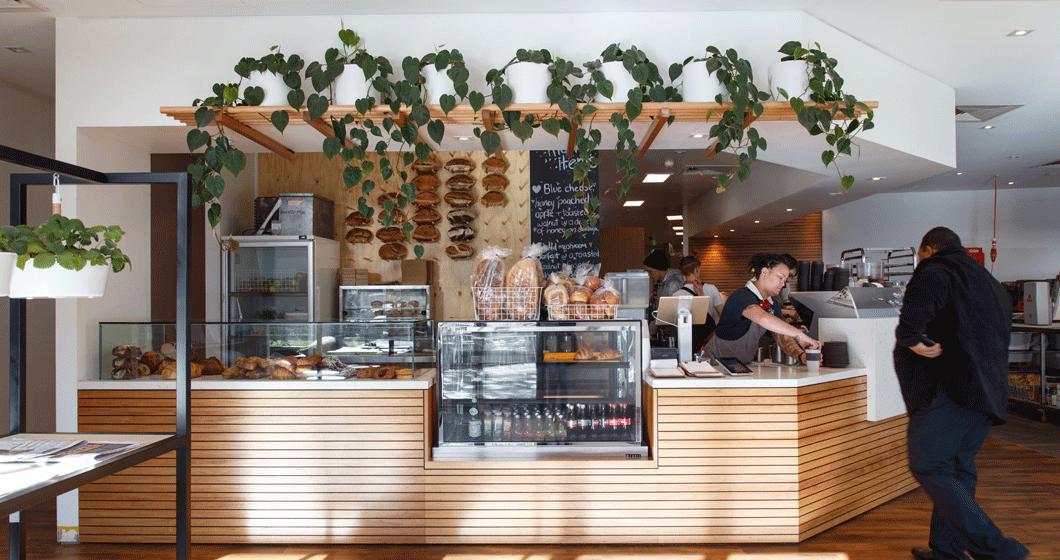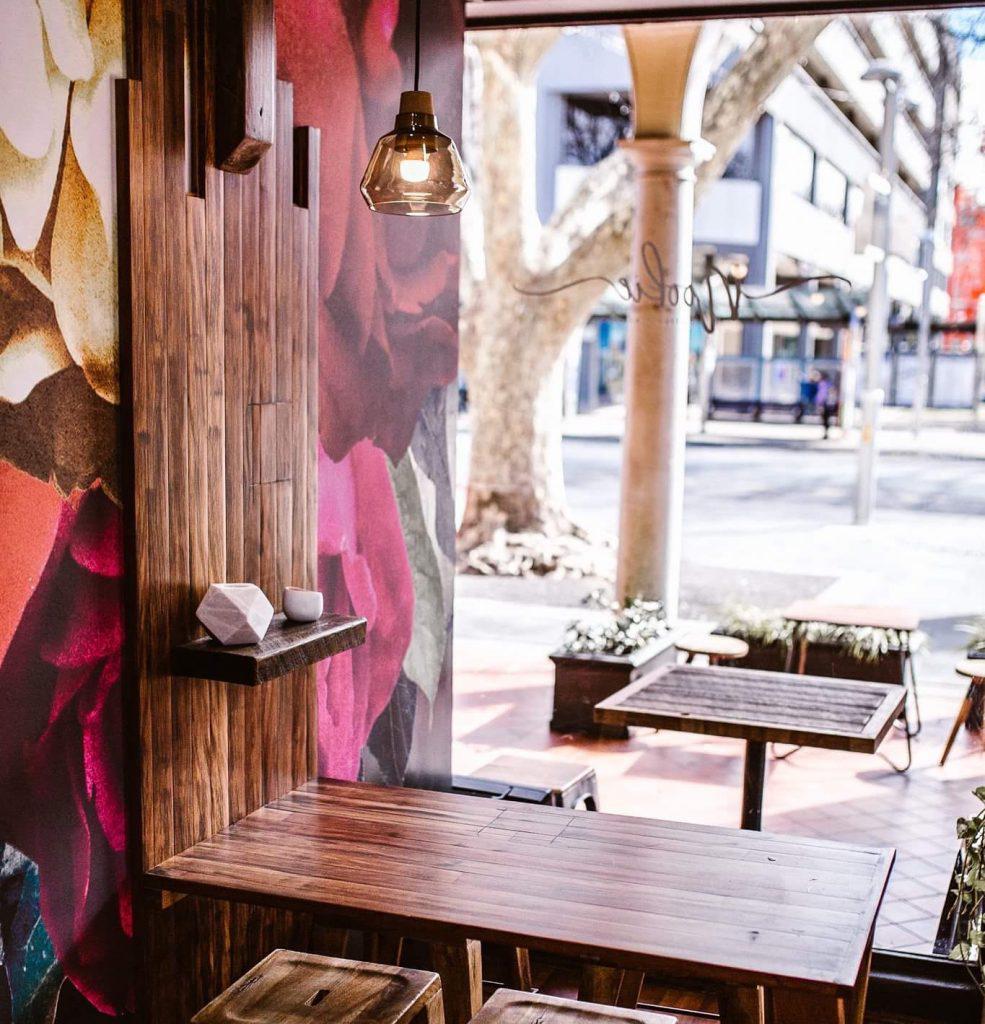The first image is the image on the left, the second image is the image on the right. For the images shown, is this caption "One person is standing alone in front of a wooden counter and at least one person is somewhere behind the counter in one image." true? Answer yes or no. Yes. 